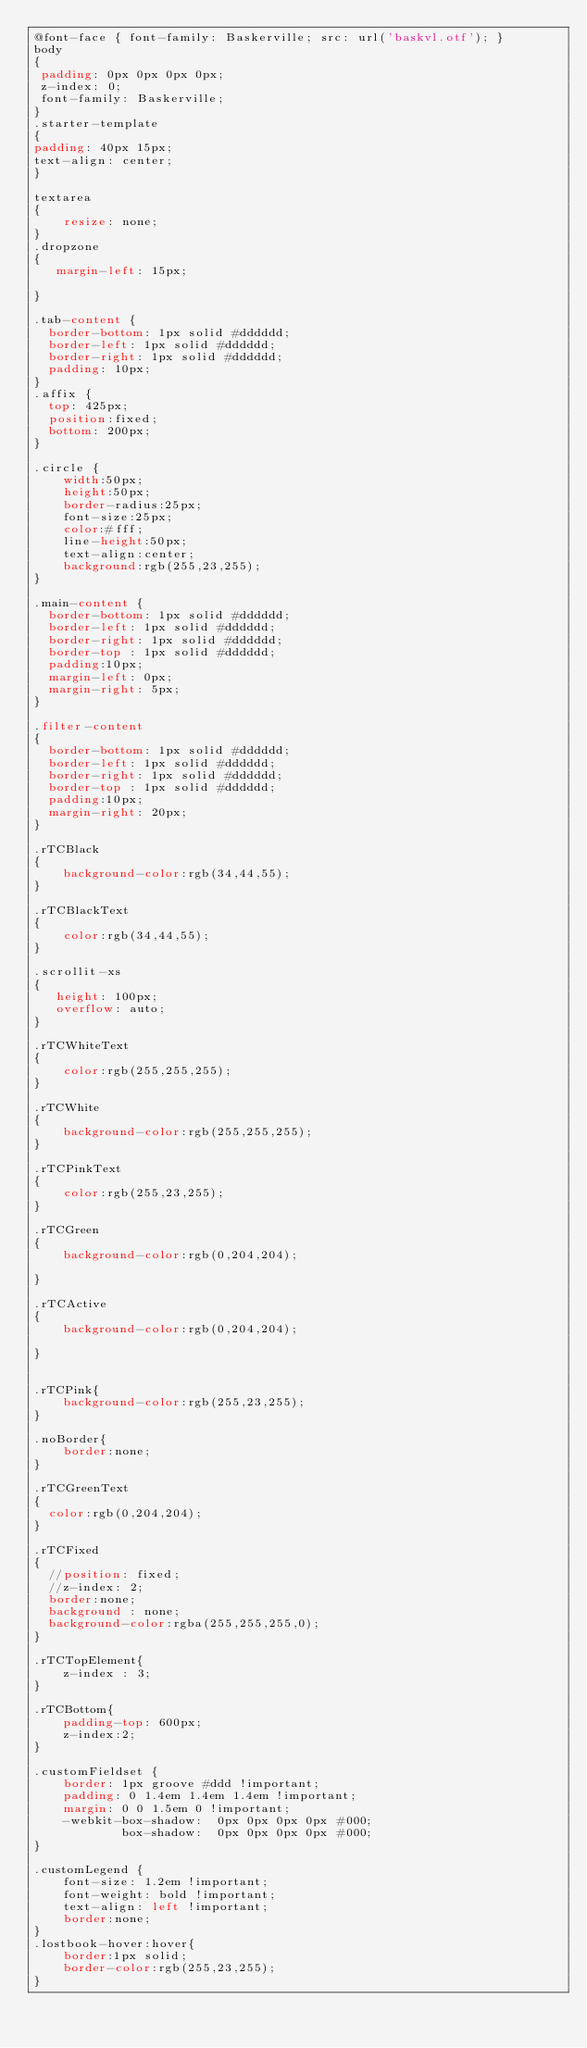<code> <loc_0><loc_0><loc_500><loc_500><_CSS_>@font-face { font-family: Baskerville; src: url('baskvl.otf'); } 
body 
{
 padding: 0px 0px 0px 0px;
 z-index: 0;
 font-family: Baskerville;
}
.starter-template 
{
padding: 40px 15px;
text-align: center;
}

textarea
{
    resize: none;
}
.dropzone
{
   margin-left: 15px;
     
}

.tab-content {
  border-bottom: 1px solid #dddddd;
  border-left: 1px solid #dddddd;
  border-right: 1px solid #dddddd;
  padding: 10px;
}
.affix {
  top: 425px;
  position:fixed;
  bottom: 200px;
}

.circle {
	width:50px;
    height:50px;
    border-radius:25px;
    font-size:25px;
    color:#fff;
    line-height:50px;
    text-align:center;
    background:rgb(255,23,255);
}

.main-content {
  border-bottom: 1px solid #dddddd;
  border-left: 1px solid #dddddd;
  border-right: 1px solid #dddddd;
  border-top : 1px solid #dddddd;
  padding:10px;
  margin-left: 0px;
  margin-right: 5px;
}

.filter-content
{
  border-bottom: 1px solid #dddddd;
  border-left: 1px solid #dddddd;
  border-right: 1px solid #dddddd;
  border-top : 1px solid #dddddd;
  padding:10px;
  margin-right: 20px;
}

.rTCBlack
{
    background-color:rgb(34,44,55);
}

.rTCBlackText
{
    color:rgb(34,44,55);
}

.scrollit-xs
{
   height: 100px;
   overflow: auto;
}

.rTCWhiteText
{
    color:rgb(255,255,255);
}

.rTCWhite
{
    background-color:rgb(255,255,255);
}

.rTCPinkText
{
    color:rgb(255,23,255);
}

.rTCGreen 
{
    background-color:rgb(0,204,204);
  
}

.rTCActive 
{
    background-color:rgb(0,204,204);
  
}


.rTCPink{
    background-color:rgb(255,23,255);
}

.noBorder{
    border:none;
}

.rTCGreenText
{
  color:rgb(0,204,204);
}

.rTCFixed
{
  //position: fixed;
  //z-index: 2;
  border:none;
  background : none;
  background-color:rgba(255,255,255,0);
}

.rTCTopElement{
    z-index : 3;
}

.rTCBottom{
    padding-top: 600px;
    z-index:2;
}

.customFieldset {
    border: 1px groove #ddd !important;
    padding: 0 1.4em 1.4em 1.4em !important;
    margin: 0 0 1.5em 0 !important;
    -webkit-box-shadow:  0px 0px 0px 0px #000;
            box-shadow:  0px 0px 0px 0px #000;
}

.customLegend {
    font-size: 1.2em !important;
    font-weight: bold !important;
    text-align: left !important;
    border:none;
}
.lostbook-hover:hover{
    border:1px solid;
    border-color:rgb(255,23,255);
}


</code> 